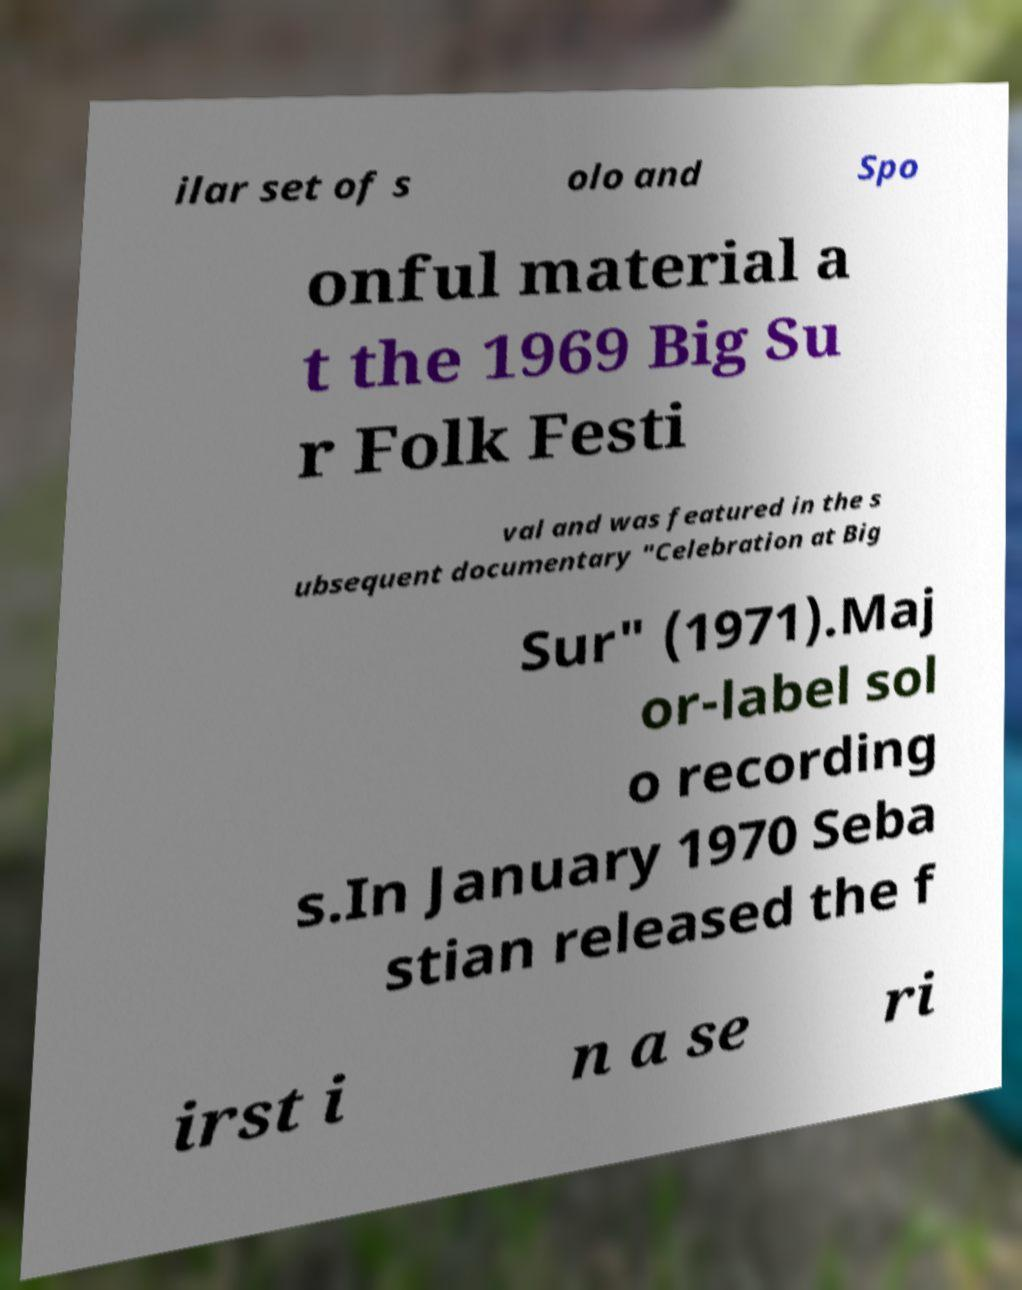Can you accurately transcribe the text from the provided image for me? ilar set of s olo and Spo onful material a t the 1969 Big Su r Folk Festi val and was featured in the s ubsequent documentary "Celebration at Big Sur" (1971).Maj or-label sol o recording s.In January 1970 Seba stian released the f irst i n a se ri 